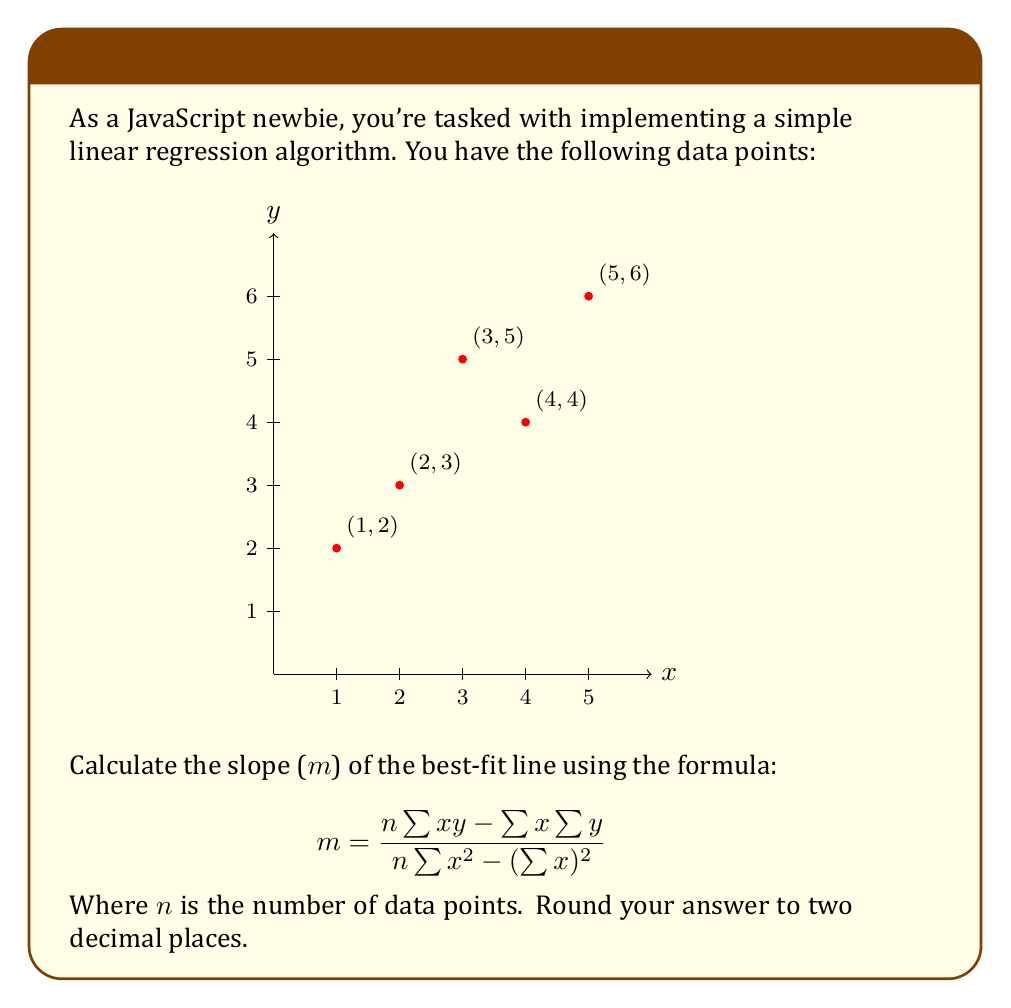Help me with this question. Let's break this down step-by-step:

1) We have 5 data points (n = 5):
   (1,2), (2,3), (3,5), (4,4), (5,6)

2) Let's calculate the components of the formula:

   $\sum{x} = 1 + 2 + 3 + 4 + 5 = 15$
   $\sum{y} = 2 + 3 + 5 + 4 + 6 = 20$
   $\sum{xy} = (1*2) + (2*3) + (3*5) + (4*4) + (5*6) = 2 + 6 + 15 + 16 + 30 = 69$
   $\sum{x^2} = 1^2 + 2^2 + 3^2 + 4^2 + 5^2 = 1 + 4 + 9 + 16 + 25 = 55$

3) Now, let's substitute these values into the formula:

   $$ m = \frac{5(69) - (15)(20)}{5(55) - (15)^2} $$

4) Simplify:

   $$ m = \frac{345 - 300}{275 - 225} $$

5) Calculate:

   $$ m = \frac{45}{50} = 0.9 $$

6) The result is already rounded to two decimal places.
Answer: 0.90 